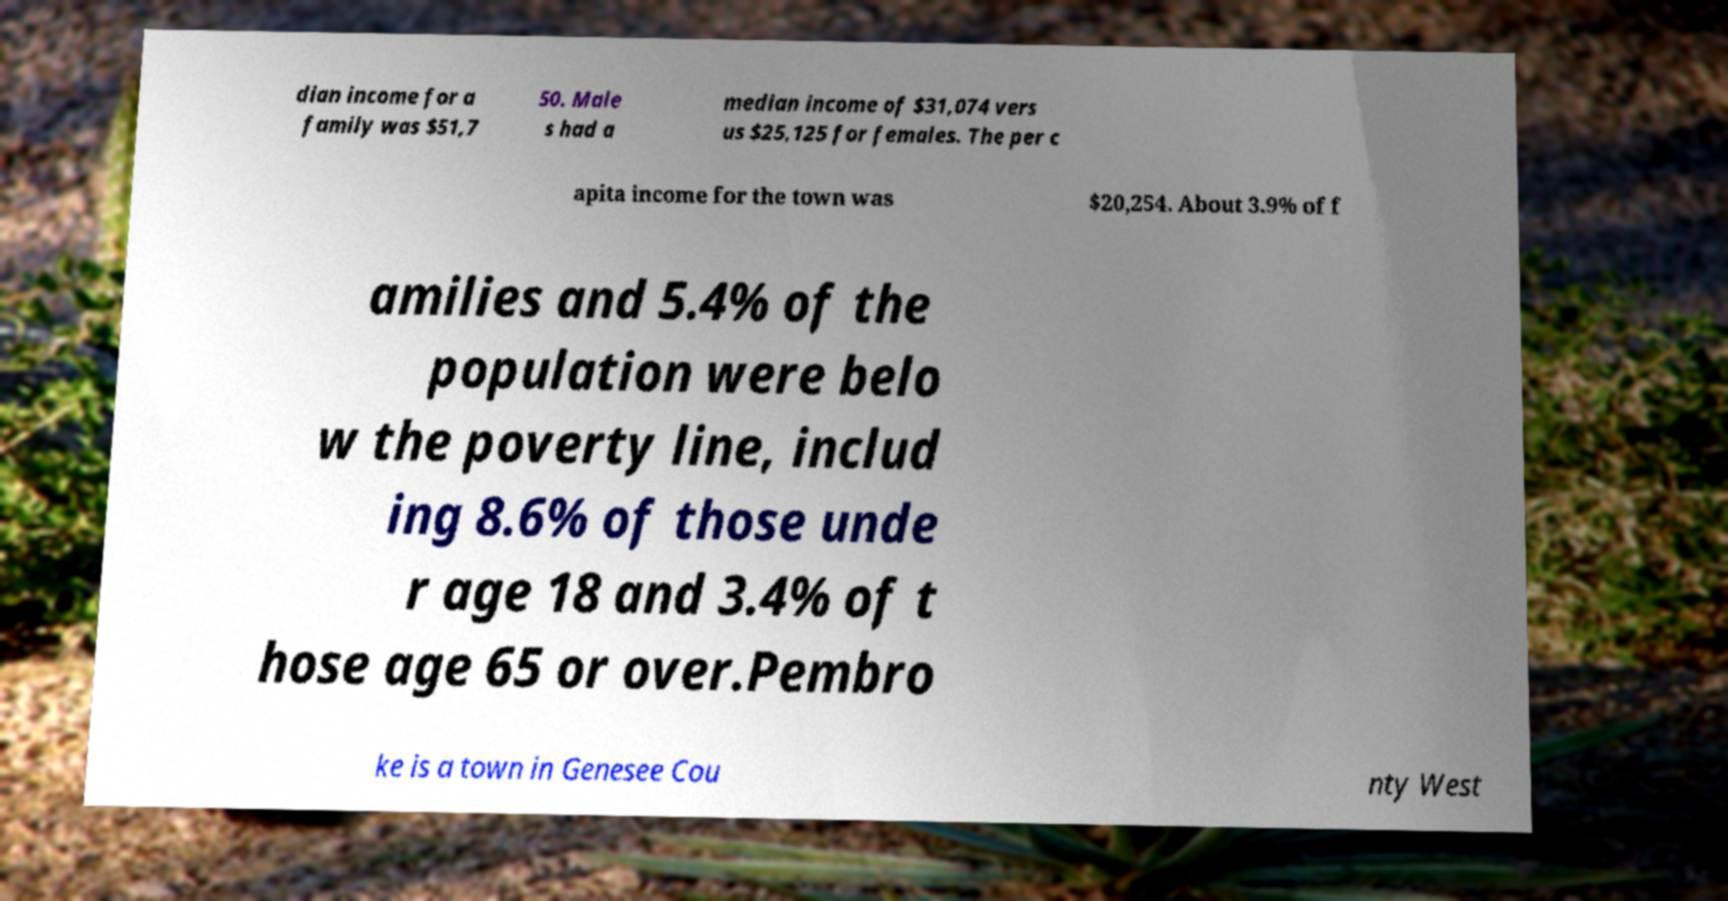I need the written content from this picture converted into text. Can you do that? dian income for a family was $51,7 50. Male s had a median income of $31,074 vers us $25,125 for females. The per c apita income for the town was $20,254. About 3.9% of f amilies and 5.4% of the population were belo w the poverty line, includ ing 8.6% of those unde r age 18 and 3.4% of t hose age 65 or over.Pembro ke is a town in Genesee Cou nty West 